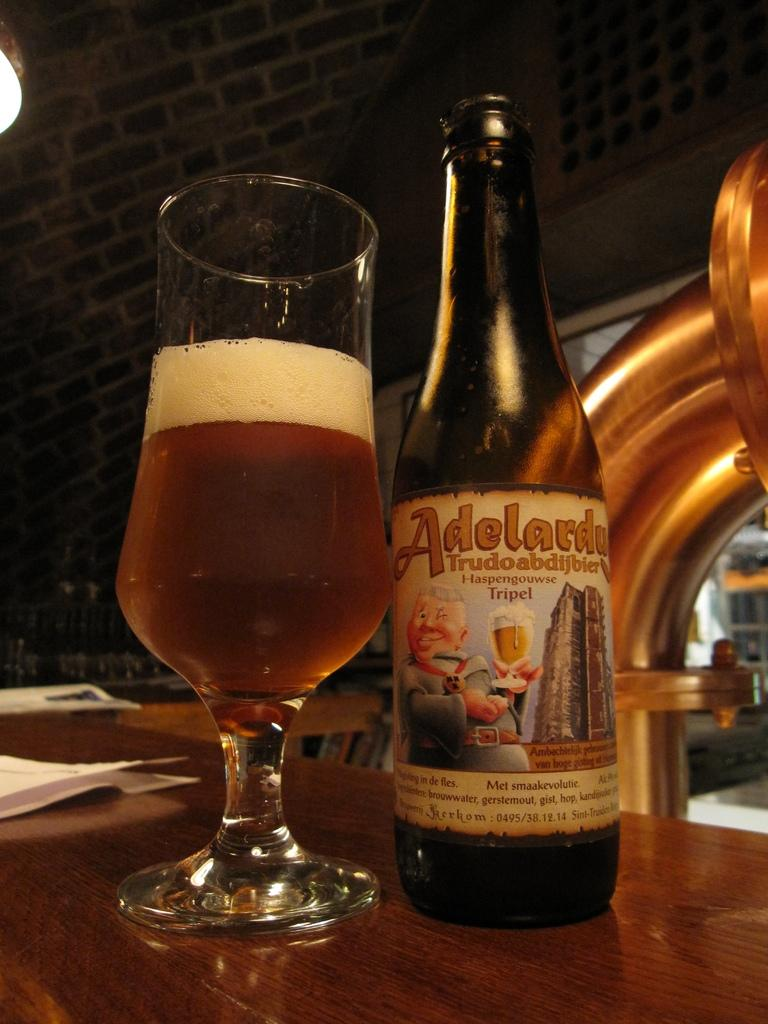<image>
Relay a brief, clear account of the picture shown. An Adelardu bottle sits next to a glass filled with amber liquid. 